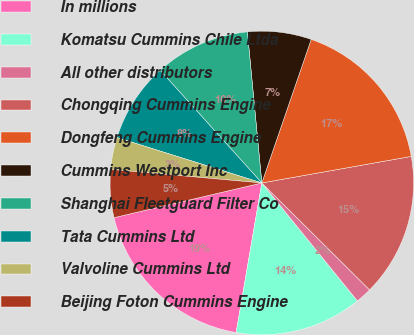<chart> <loc_0><loc_0><loc_500><loc_500><pie_chart><fcel>In millions<fcel>Komatsu Cummins Chile Ltda<fcel>All other distributors<fcel>Chongqing Cummins Engine<fcel>Dongfeng Cummins Engine<fcel>Cummins Westport Inc<fcel>Shanghai Fleetguard Filter Co<fcel>Tata Cummins Ltd<fcel>Valvoline Cummins Ltd<fcel>Beijing Foton Cummins Engine<nl><fcel>18.62%<fcel>13.55%<fcel>1.72%<fcel>15.24%<fcel>16.93%<fcel>6.79%<fcel>10.17%<fcel>8.48%<fcel>3.41%<fcel>5.1%<nl></chart> 